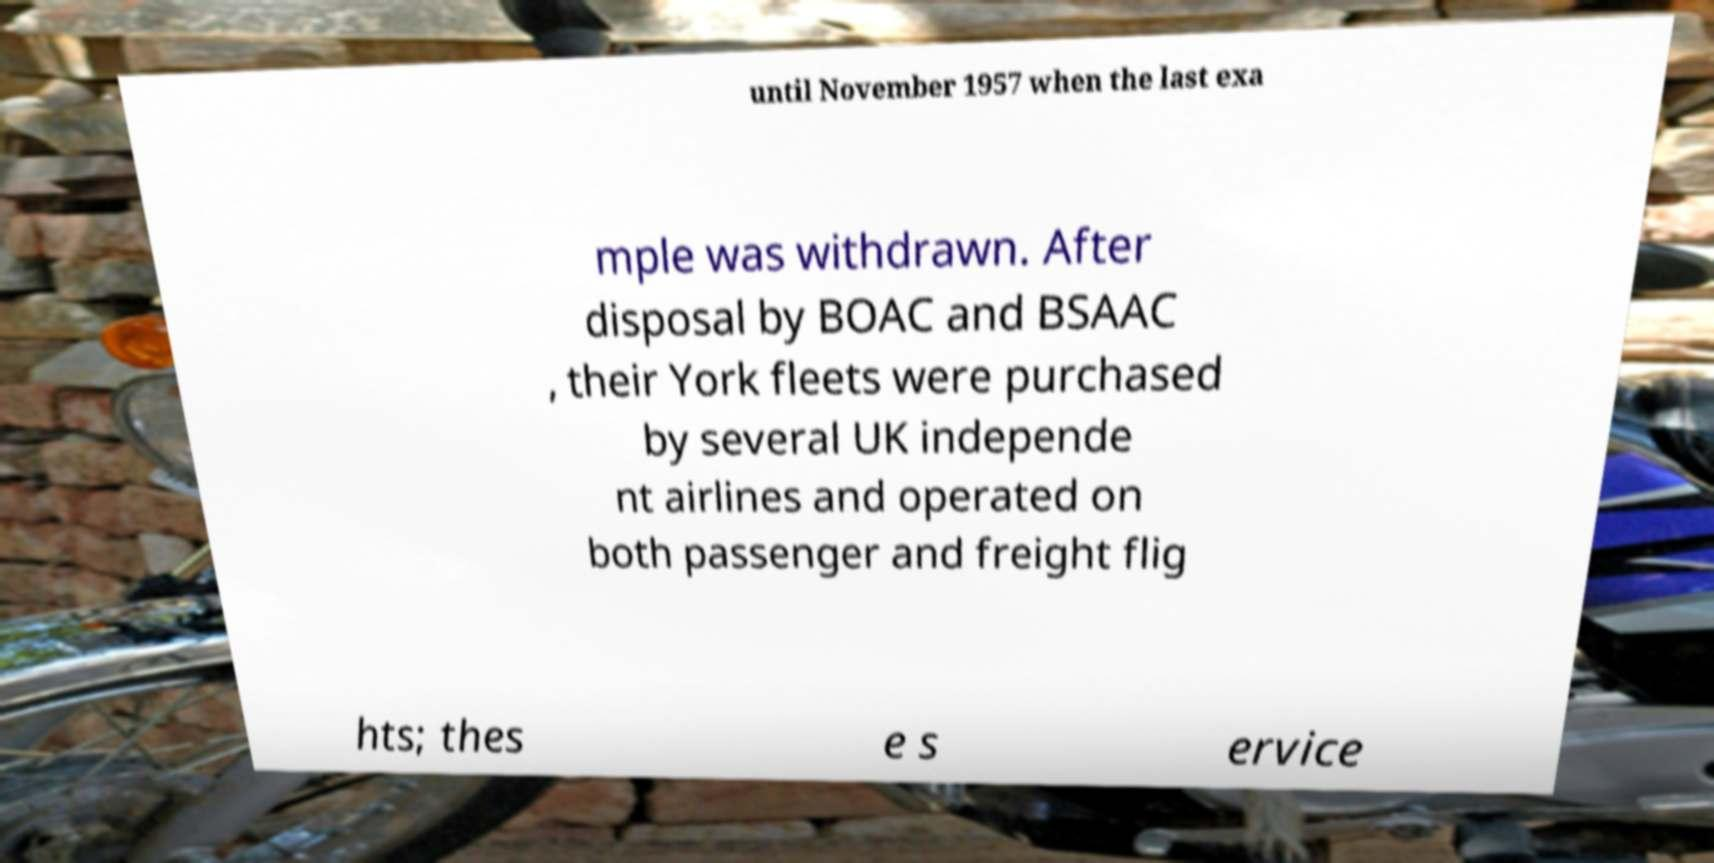Please read and relay the text visible in this image. What does it say? until November 1957 when the last exa mple was withdrawn. After disposal by BOAC and BSAAC , their York fleets were purchased by several UK independe nt airlines and operated on both passenger and freight flig hts; thes e s ervice 